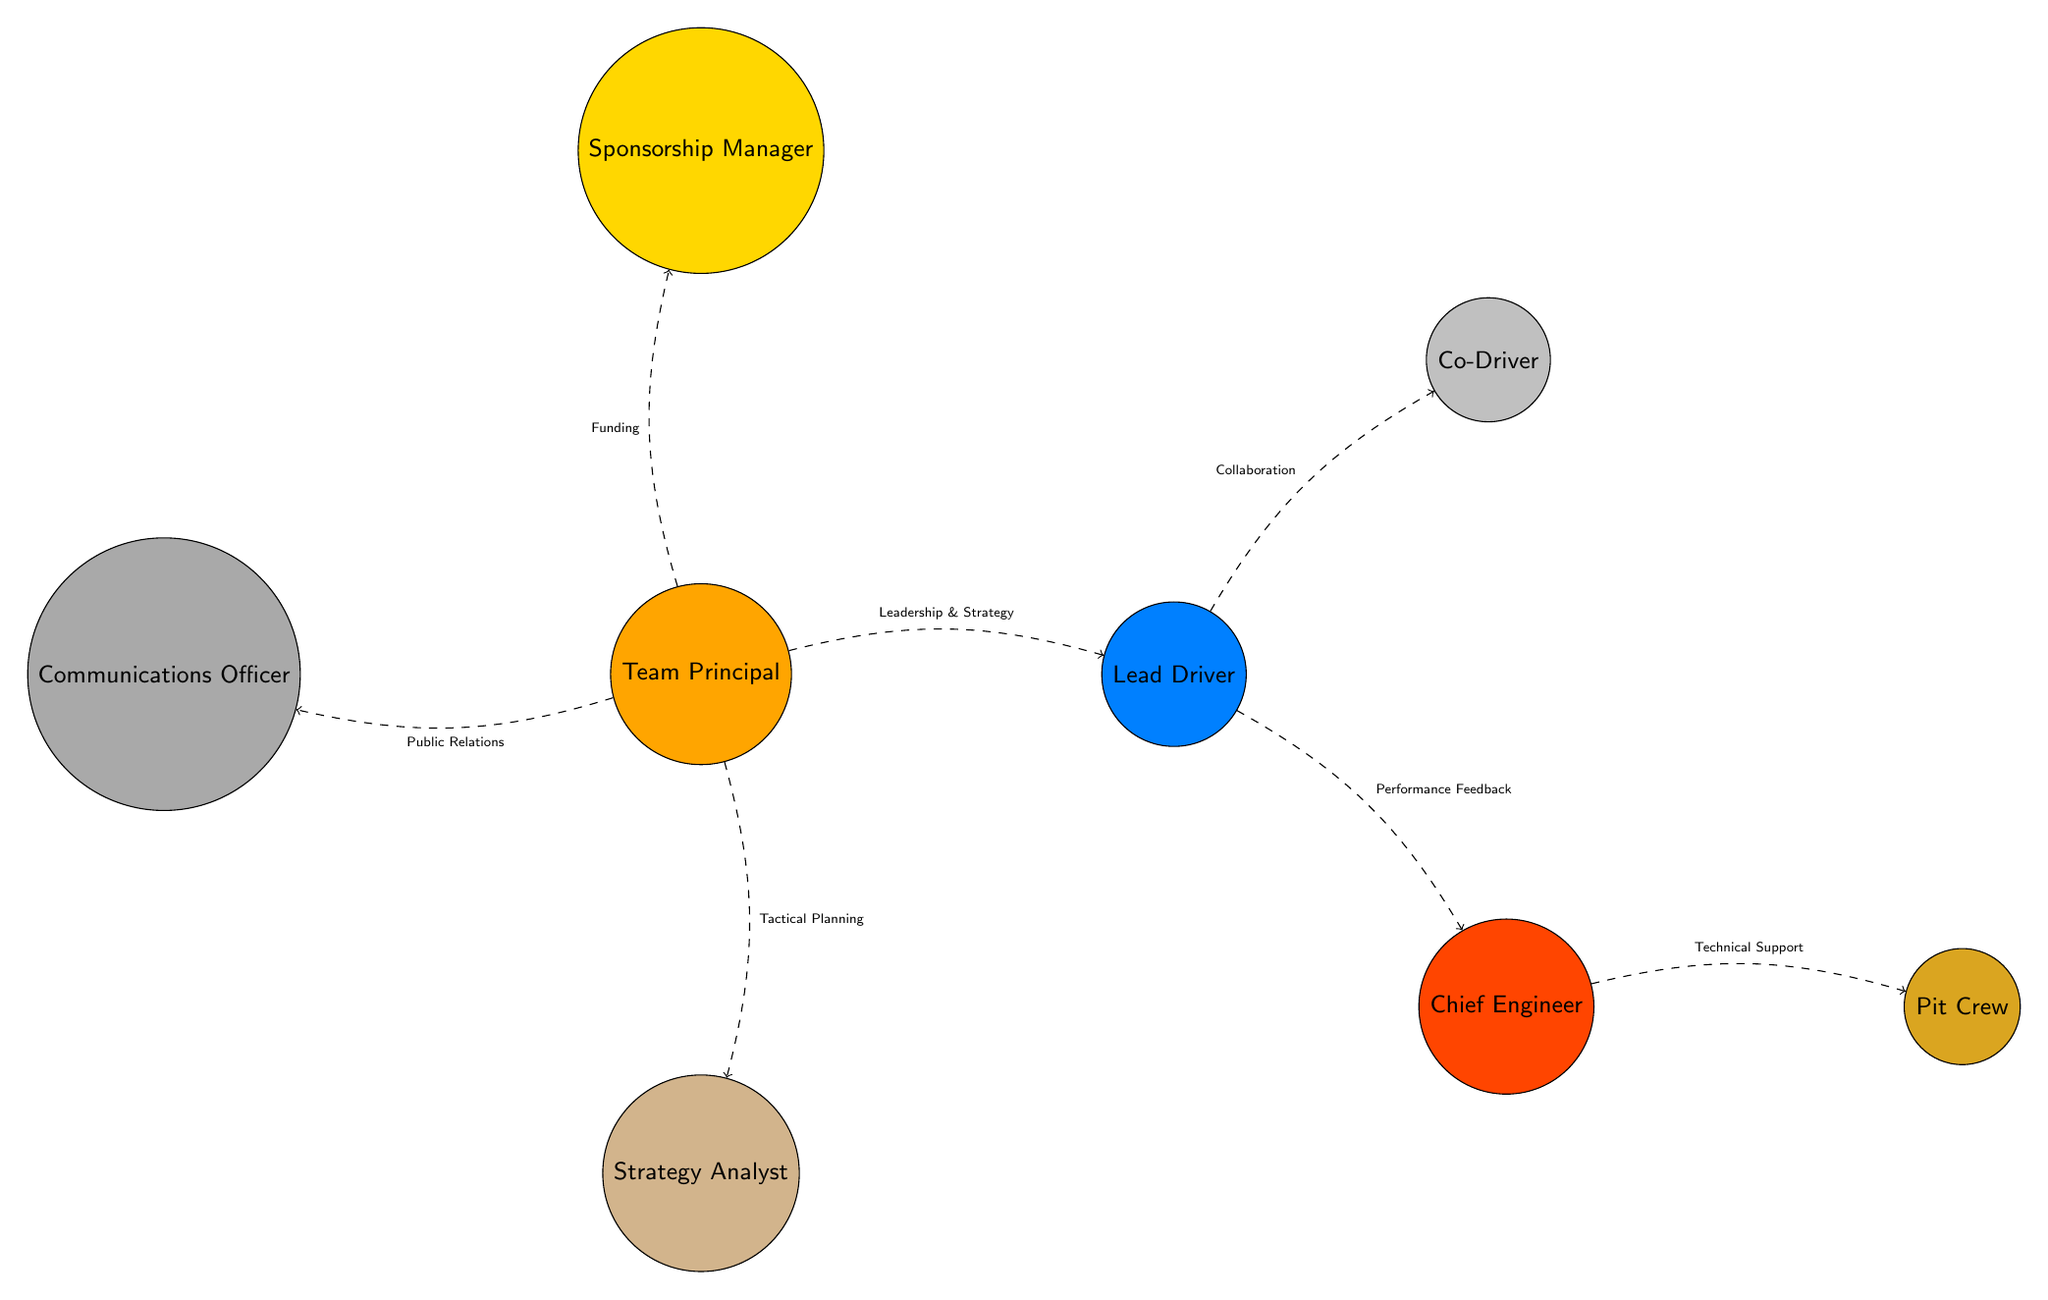What role does the sun represent in the diagram? In the diagram, the sun is labeled as "Team Principal". It is the central figure from which other roles and relationships radiate out.
Answer: Team Principal How many planets are depicted in the diagram? The diagram includes a total of 8 planets, each representing different roles within the Ciceley Motorsport team.
Answer: 8 Which planet is closest to the sun? The planet closest to the sun in the diagram is "Lead Driver", positioned directly to the right of the sun.
Answer: Lead Driver What type of relationship exists between the Lead Driver and Co-Driver? The relationship between the Lead Driver and Co-Driver is labeled as "Collaboration", signifying cooperative efforts between these two roles.
Answer: Collaboration What represents the relationship between the Team Principal and Strategy Analyst? The relationship is labeled as "Tactical Planning", showing that the Team Principal provides strategic oversight to the Strategy Analyst.
Answer: Tactical Planning How does the Chief Engineer contribute to the Pit Crew according to the diagram? The Chief Engineer provides "Technical Support" to the Pit Crew, indicating a crucial link in operations and performance.
Answer: Technical Support Which role is linked to both public relations and funding in the diagram? The "Team Principal" is linked to both "Public Relations" (Communications Officer) and "Funding" (Sponsorship Manager), indicating their central role in managing key aspects of the team.
Answer: Team Principal What color is used to represent Mars in the diagram? Mars is represented in the color "RGB: 255,69,0", which gives it a distinct appearance in the diagram.
Answer: RGB: 255,69,0 